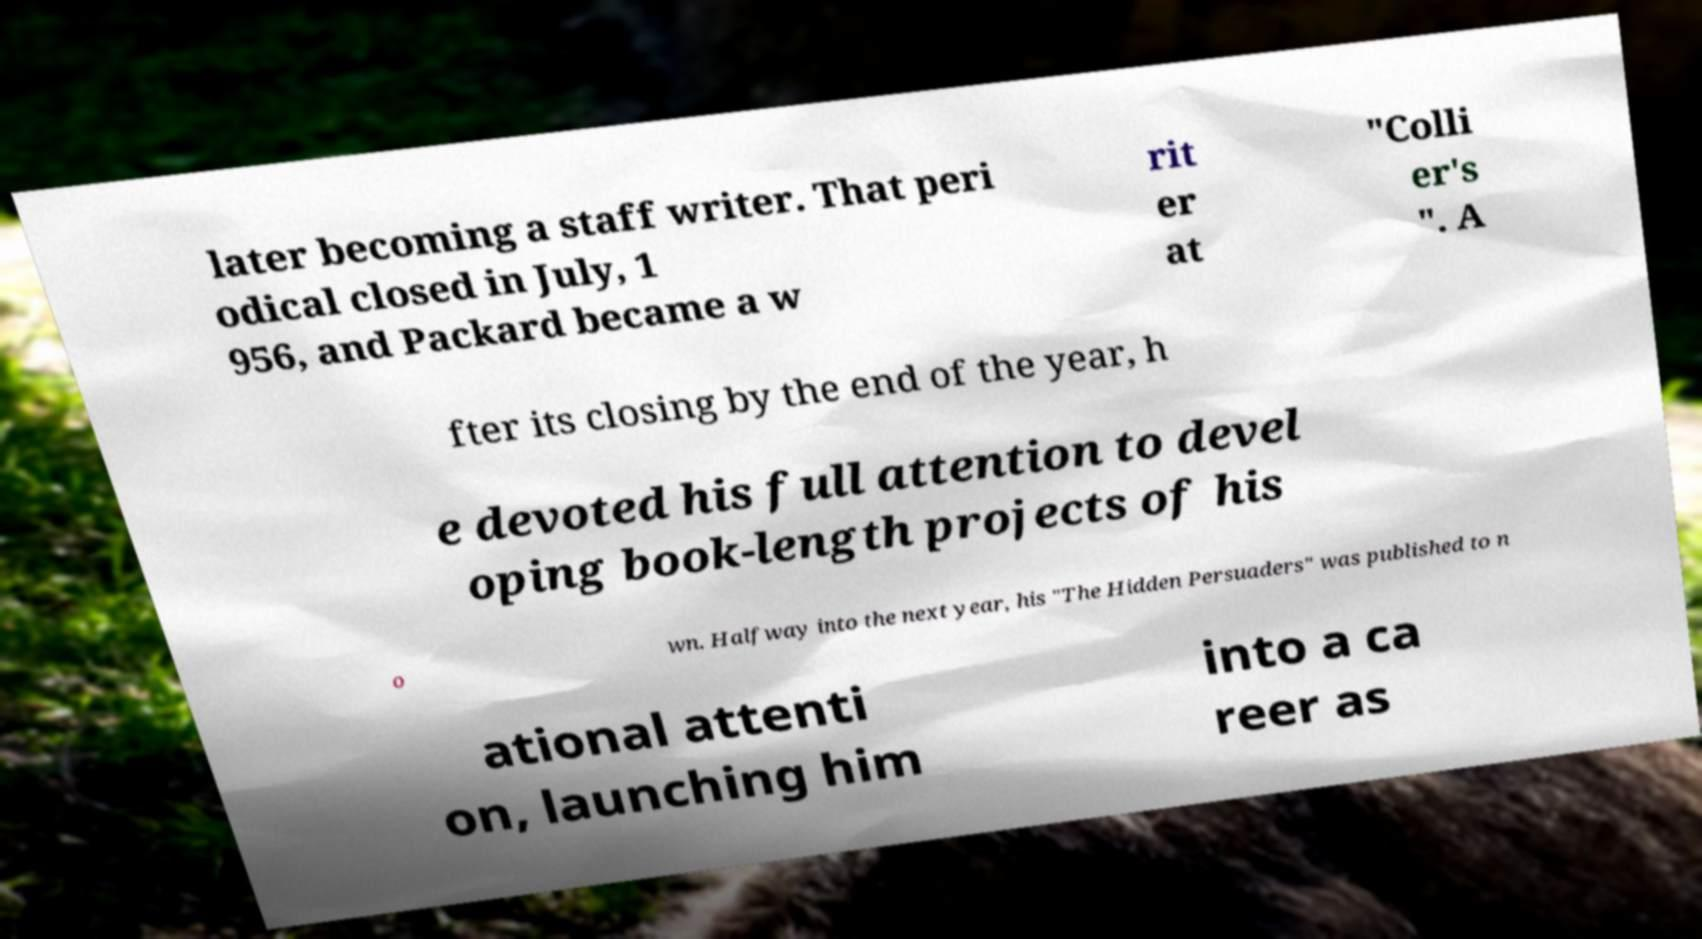What messages or text are displayed in this image? I need them in a readable, typed format. later becoming a staff writer. That peri odical closed in July, 1 956, and Packard became a w rit er at "Colli er's ". A fter its closing by the end of the year, h e devoted his full attention to devel oping book-length projects of his o wn. Halfway into the next year, his "The Hidden Persuaders" was published to n ational attenti on, launching him into a ca reer as 